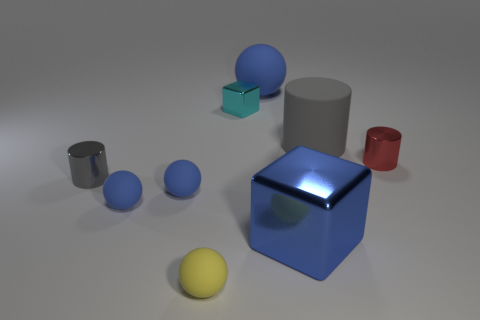Subtract all large blue rubber balls. How many balls are left? 3 Subtract all brown balls. How many gray cylinders are left? 2 Add 1 tiny blue shiny blocks. How many objects exist? 10 Subtract all yellow spheres. How many spheres are left? 3 Subtract all cylinders. How many objects are left? 6 Subtract all green cylinders. Subtract all purple cubes. How many cylinders are left? 3 Subtract all small cubes. Subtract all tiny blue matte spheres. How many objects are left? 6 Add 9 tiny yellow balls. How many tiny yellow balls are left? 10 Add 9 tiny gray shiny objects. How many tiny gray shiny objects exist? 10 Subtract 0 purple cylinders. How many objects are left? 9 